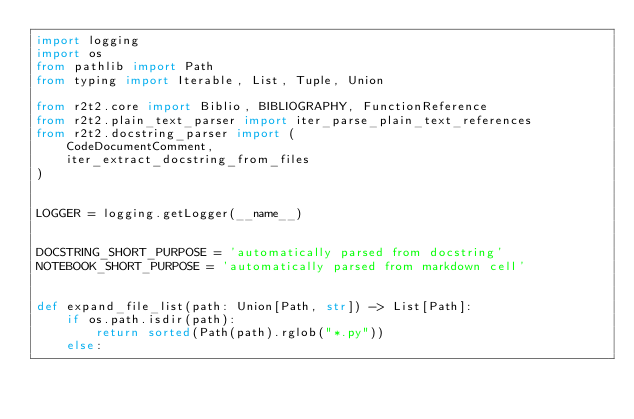<code> <loc_0><loc_0><loc_500><loc_500><_Python_>import logging
import os
from pathlib import Path
from typing import Iterable, List, Tuple, Union

from r2t2.core import Biblio, BIBLIOGRAPHY, FunctionReference
from r2t2.plain_text_parser import iter_parse_plain_text_references
from r2t2.docstring_parser import (
    CodeDocumentComment,
    iter_extract_docstring_from_files
)


LOGGER = logging.getLogger(__name__)


DOCSTRING_SHORT_PURPOSE = 'automatically parsed from docstring'
NOTEBOOK_SHORT_PURPOSE = 'automatically parsed from markdown cell'


def expand_file_list(path: Union[Path, str]) -> List[Path]:
    if os.path.isdir(path):
        return sorted(Path(path).rglob("*.py"))
    else:</code> 